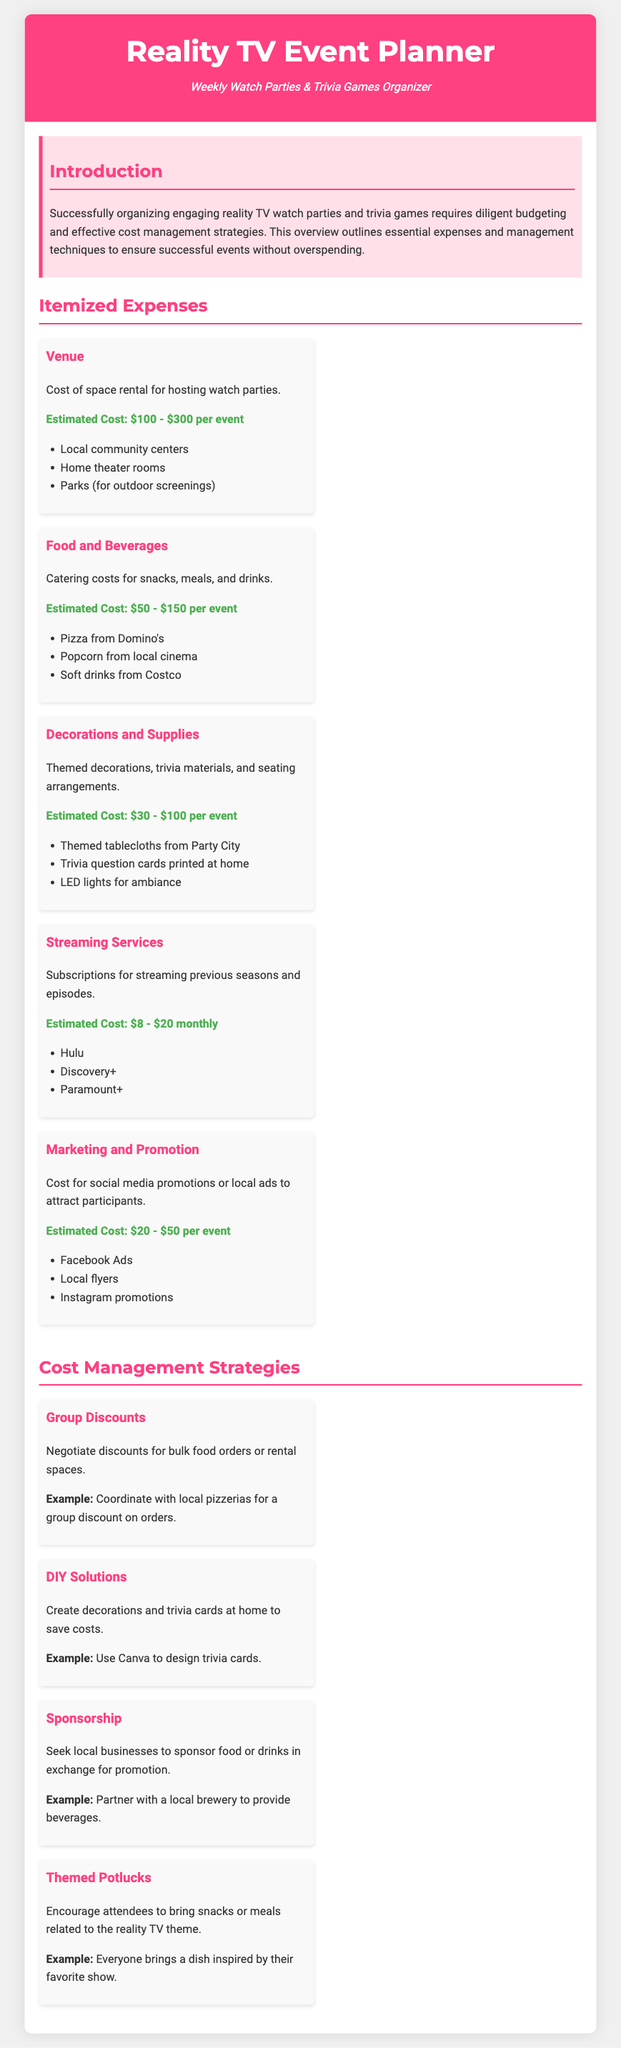What is the estimated cost for the venue? The document states that the estimated cost for the venue is between $100 and $300 per event.
Answer: $100 - $300 per event What are two examples of food and beverage options? The document lists pizza from Domino's and soft drinks from Costco as examples of food and beverage options.
Answer: Pizza from Domino's, Soft drinks from Costco What is one cost management strategy mentioned? The document outlines various strategies, including "Group Discounts" as a method to manage costs.
Answer: Group Discounts What is the estimated cost for decorations and supplies? The document indicates that the estimated cost for decorations and supplies is between $30 and $100 per event.
Answer: $30 - $100 per event How much is the estimated monthly cost for streaming services? The document provides an estimated monthly cost for streaming services as $8 to $20.
Answer: $8 - $20 monthly What is the purpose of marketing and promotion expenditures? The document states that marketing and promotion costs are for attracting participants to the events.
Answer: Attracting participants How can attendees contribute to the event in a themed potluck? The document suggests that attendees can bring snacks or meals related to the reality TV theme.
Answer: Bring snacks or meals related to the reality TV theme What type of decorations does the planner suggest using? The document mentions using themed tablecloths as a decoration suggestion.
Answer: Themed tablecloths What is one example of a streaming service mentioned in the itemized expenses? The document lists Hulu as an example of a streaming service included in the expenses.
Answer: Hulu 